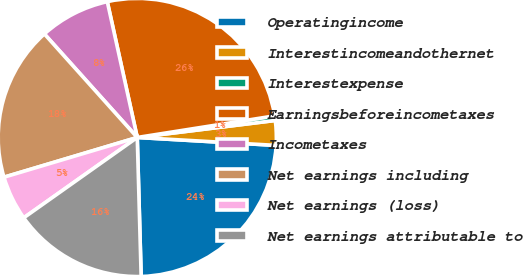Convert chart to OTSL. <chart><loc_0><loc_0><loc_500><loc_500><pie_chart><fcel>Operatingincome<fcel>Interestincomeandothernet<fcel>Interestexpense<fcel>Earningsbeforeincometaxes<fcel>Incometaxes<fcel>Net earnings including<fcel>Net earnings (loss)<fcel>Net earnings attributable to<nl><fcel>23.64%<fcel>2.86%<fcel>0.53%<fcel>25.97%<fcel>8.18%<fcel>17.97%<fcel>5.19%<fcel>15.64%<nl></chart> 